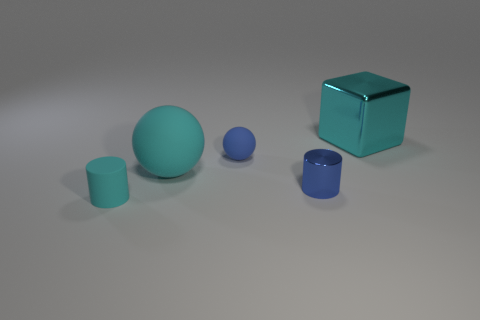Add 1 small rubber balls. How many objects exist? 6 Subtract all balls. How many objects are left? 3 Subtract 1 blue cylinders. How many objects are left? 4 Subtract all cyan metal objects. Subtract all tiny spheres. How many objects are left? 3 Add 5 large metal blocks. How many large metal blocks are left? 6 Add 4 large purple metal spheres. How many large purple metal spheres exist? 4 